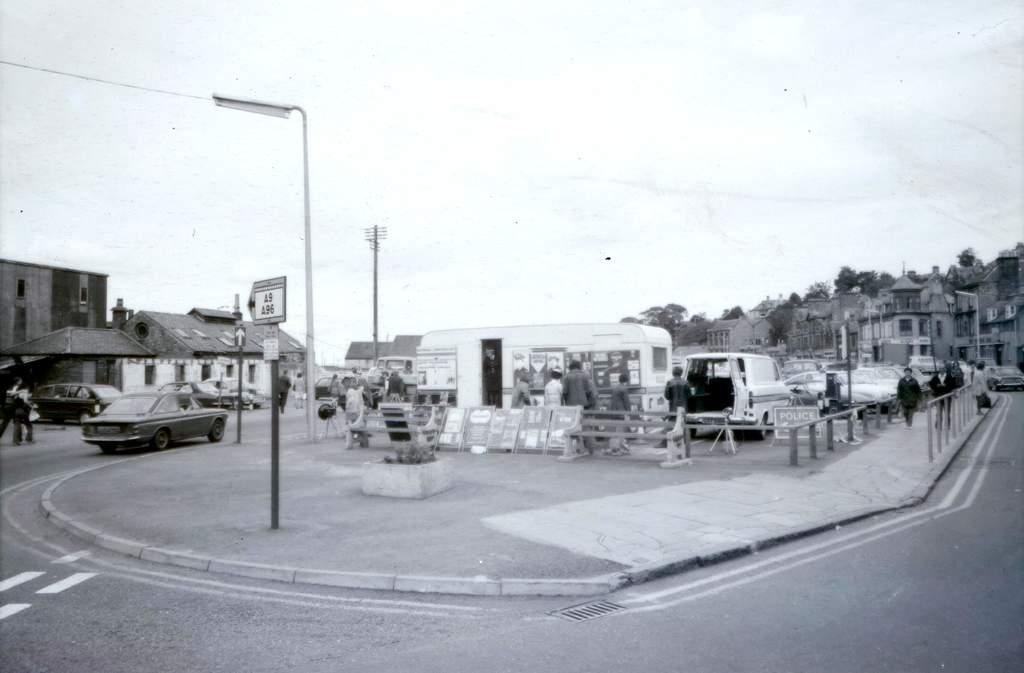In one or two sentences, can you explain what this image depicts? It is a black and white picture. In the center of the image we can see the sky, buildings, trees, vehicles, poles, sign boards, few people and a few other objects. 